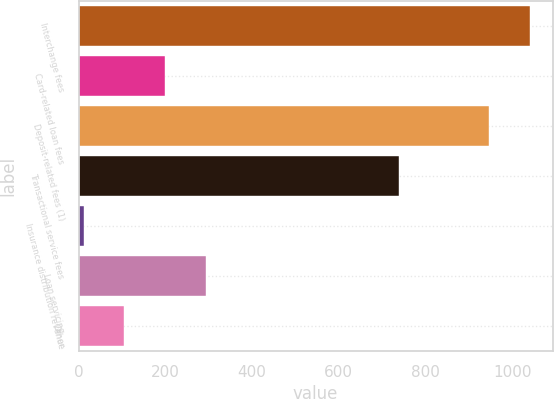<chart> <loc_0><loc_0><loc_500><loc_500><bar_chart><fcel>Interchange fees<fcel>Card-related loan fees<fcel>Deposit-related fees (1)<fcel>Transactional service fees<fcel>Insurance distribution revenue<fcel>Loan servicing<fcel>Other<nl><fcel>1040.8<fcel>199.6<fcel>947<fcel>738<fcel>12<fcel>293.4<fcel>105.8<nl></chart> 